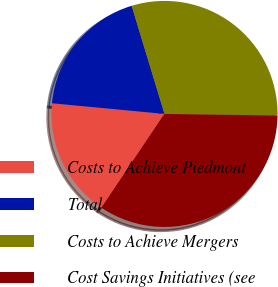Convert chart. <chart><loc_0><loc_0><loc_500><loc_500><pie_chart><fcel>Costs to Achieve Piedmont<fcel>Total<fcel>Costs to Achieve Mergers<fcel>Cost Savings Initiatives (see<nl><fcel>17.09%<fcel>18.8%<fcel>29.91%<fcel>34.19%<nl></chart> 